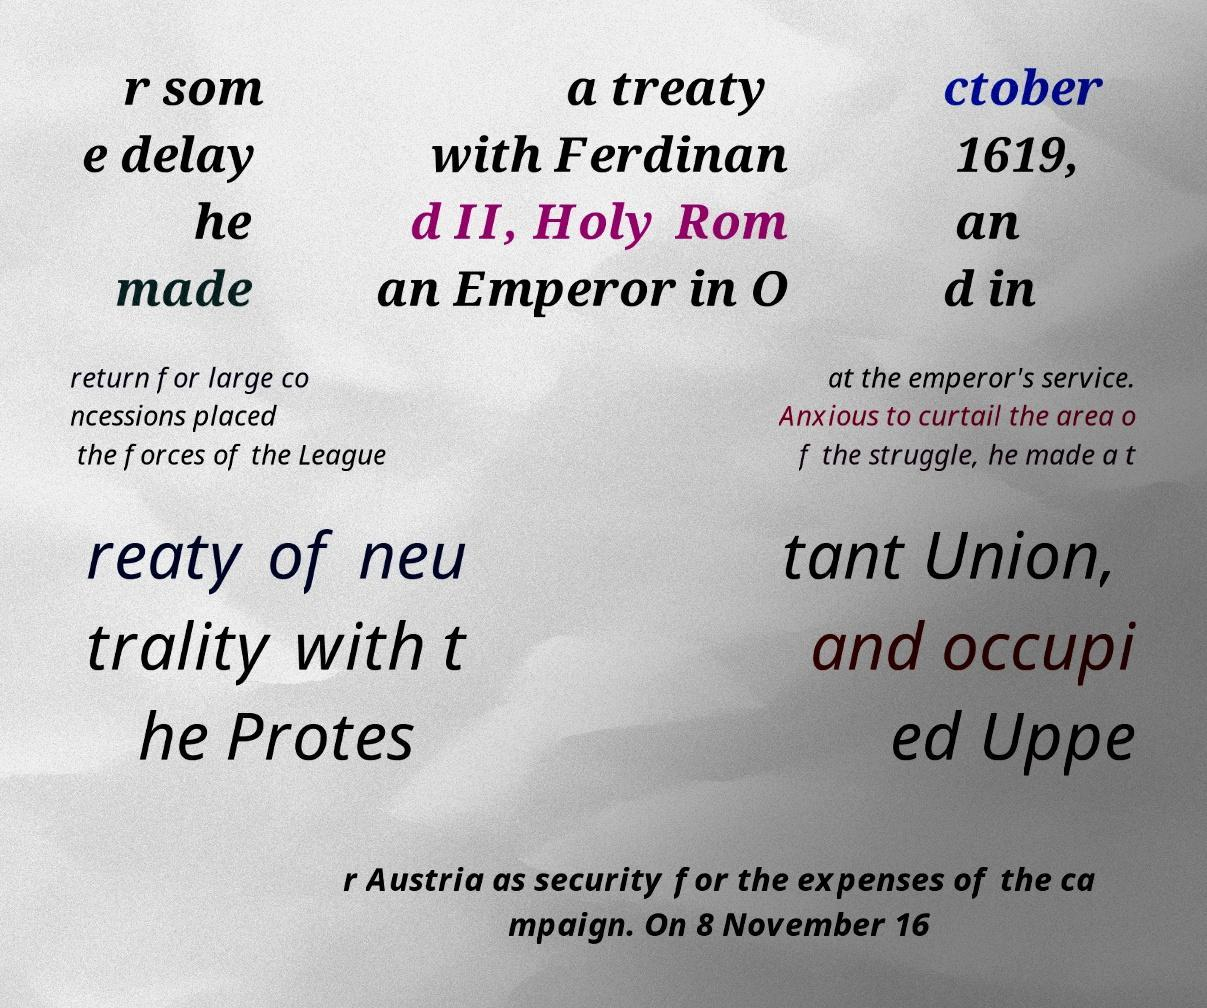There's text embedded in this image that I need extracted. Can you transcribe it verbatim? r som e delay he made a treaty with Ferdinan d II, Holy Rom an Emperor in O ctober 1619, an d in return for large co ncessions placed the forces of the League at the emperor's service. Anxious to curtail the area o f the struggle, he made a t reaty of neu trality with t he Protes tant Union, and occupi ed Uppe r Austria as security for the expenses of the ca mpaign. On 8 November 16 